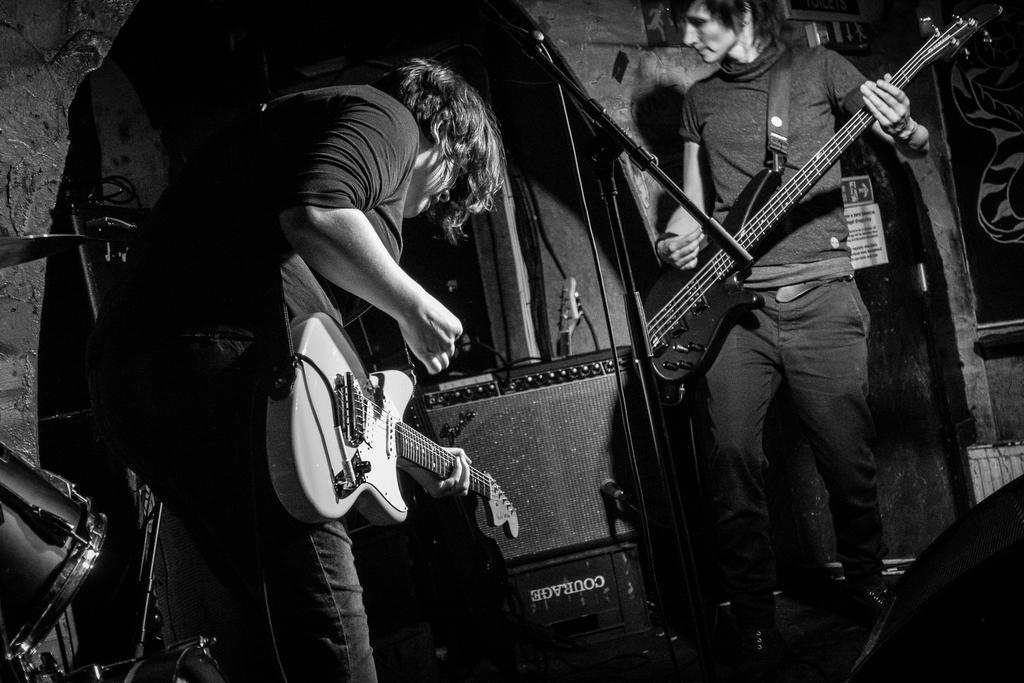Could you give a brief overview of what you see in this image? In this picture there are two men who are playing a guitar. There is a drum. 